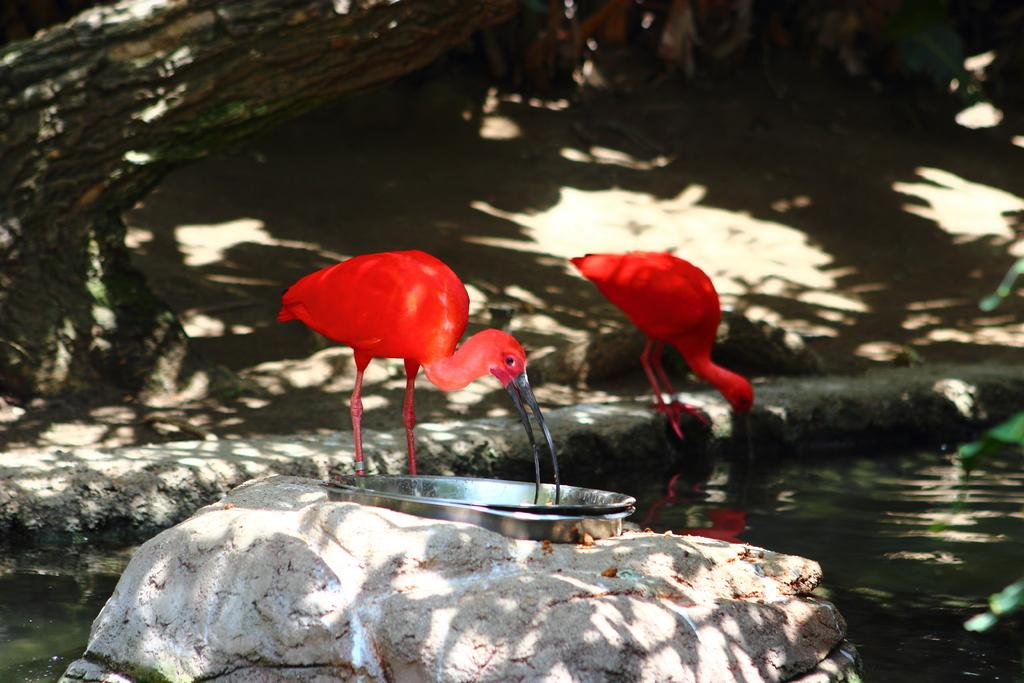What animals are in the foreground of the image? There are two ibis in the foreground of the image. What object can be seen in the image besides the ibis? There is a stone in the image. What is placed on the stone? There are plates on the stone. What natural element is visible in the image? Water is visible in the image. What part of a tree can be seen at the top of the image? The trunk of a tree is visible at the top of the image. What type of jelly is being served on the plates in the image? There is no jelly present in the image; only plates are placed on the stone. What kind of feast is taking place in the image? There is no feast depicted in the image; it simply shows two ibis, a stone, plates, water, and a tree trunk. 